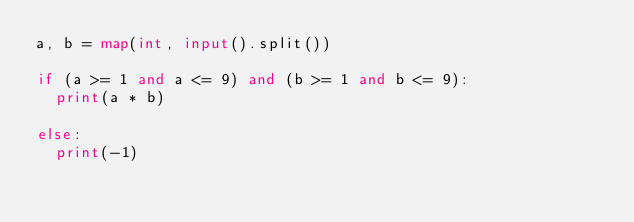<code> <loc_0><loc_0><loc_500><loc_500><_Python_>a, b = map(int, input().split())
 
if (a >= 1 and a <= 9) and (b >= 1 and b <= 9):
  print(a * b)
  
else:
  print(-1)</code> 